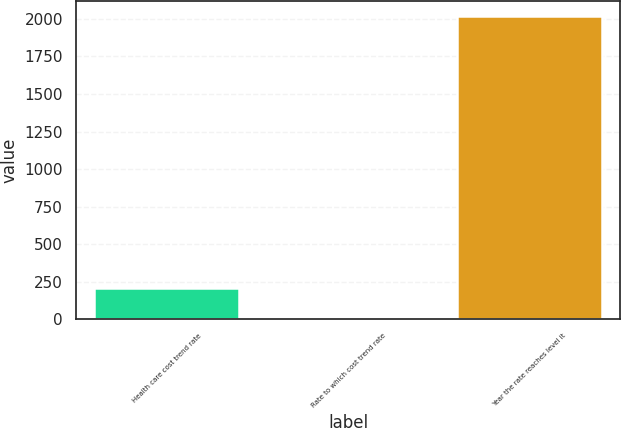<chart> <loc_0><loc_0><loc_500><loc_500><bar_chart><fcel>Health care cost trend rate<fcel>Rate to which cost trend rate<fcel>Year the rate reaches level it<nl><fcel>206.5<fcel>5<fcel>2020<nl></chart> 